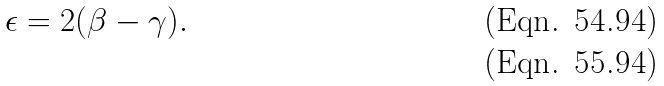Convert formula to latex. <formula><loc_0><loc_0><loc_500><loc_500>\epsilon = 2 ( \beta - \gamma ) . \\</formula> 